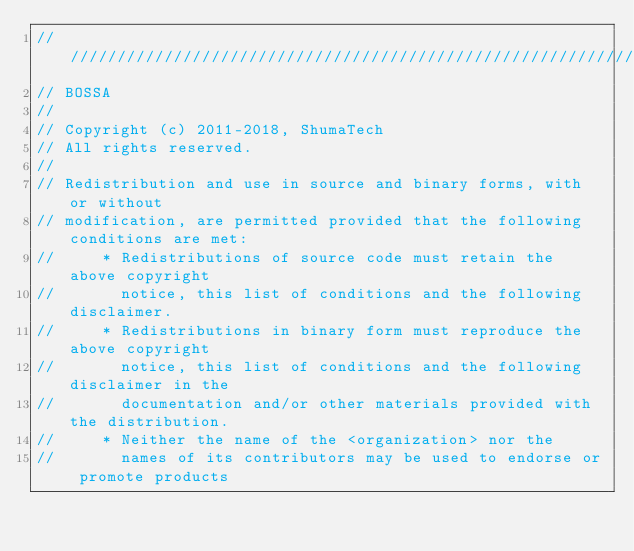<code> <loc_0><loc_0><loc_500><loc_500><_C++_>///////////////////////////////////////////////////////////////////////////////
// BOSSA
//
// Copyright (c) 2011-2018, ShumaTech
// All rights reserved.
//
// Redistribution and use in source and binary forms, with or without
// modification, are permitted provided that the following conditions are met:
//     * Redistributions of source code must retain the above copyright
//       notice, this list of conditions and the following disclaimer.
//     * Redistributions in binary form must reproduce the above copyright
//       notice, this list of conditions and the following disclaimer in the
//       documentation and/or other materials provided with the distribution.
//     * Neither the name of the <organization> nor the
//       names of its contributors may be used to endorse or promote products</code> 